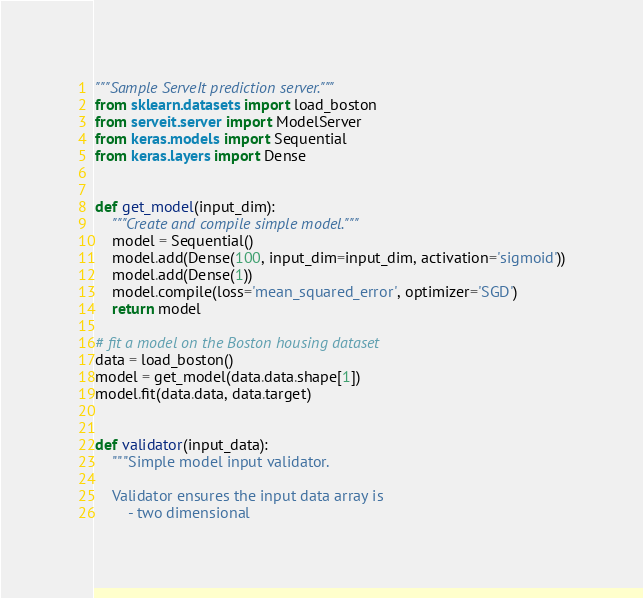<code> <loc_0><loc_0><loc_500><loc_500><_Python_>"""Sample ServeIt prediction server."""
from sklearn.datasets import load_boston
from serveit.server import ModelServer
from keras.models import Sequential
from keras.layers import Dense


def get_model(input_dim):
    """Create and compile simple model."""
    model = Sequential()
    model.add(Dense(100, input_dim=input_dim, activation='sigmoid'))
    model.add(Dense(1))
    model.compile(loss='mean_squared_error', optimizer='SGD')
    return model

# fit a model on the Boston housing dataset
data = load_boston()
model = get_model(data.data.shape[1])
model.fit(data.data, data.target)


def validator(input_data):
    """Simple model input validator.

    Validator ensures the input data array is
        - two dimensional</code> 